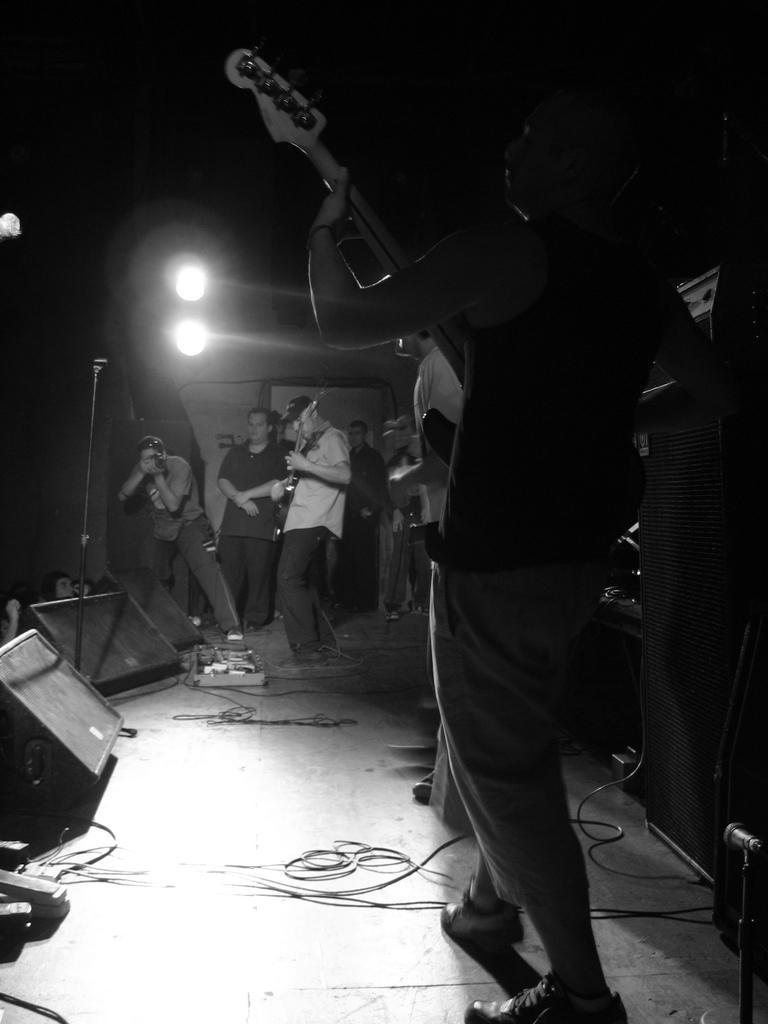Please provide a concise description of this image. Background is very dark. Here we can see persons standing and playing guitars on the platform. We can see a man standing here and holding a camera in his hands and taking snap. These are lights. We can see wires o n the platform. 